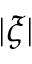Convert formula to latex. <formula><loc_0><loc_0><loc_500><loc_500>| \xi |</formula> 